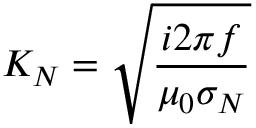Convert formula to latex. <formula><loc_0><loc_0><loc_500><loc_500>K _ { N } = \sqrt { \frac { i 2 \pi f } { \mu _ { 0 } \sigma _ { N } } }</formula> 